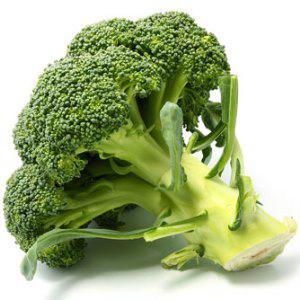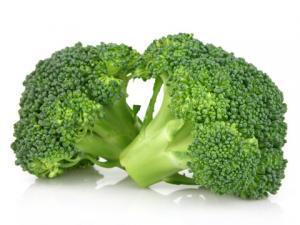The first image is the image on the left, the second image is the image on the right. Considering the images on both sides, is "A total of three cut broccoli florets are shown." valid? Answer yes or no. Yes. 